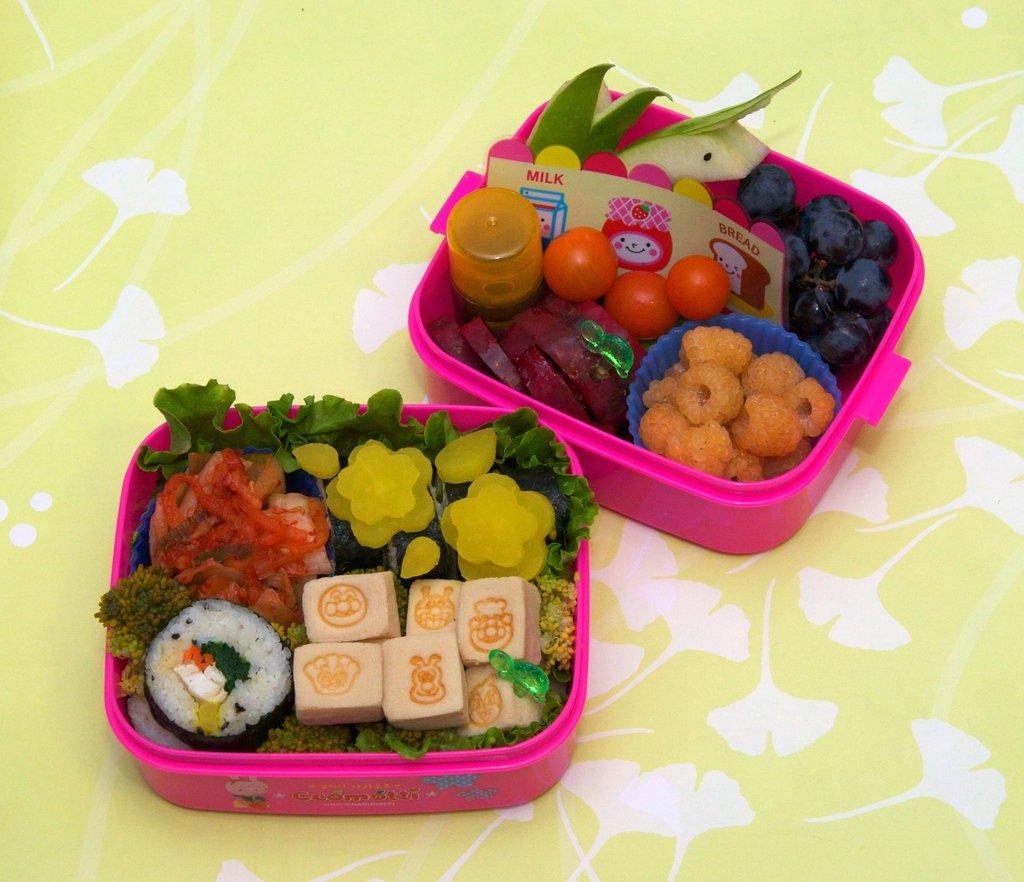What types of items are visible in the image? There are food items in the image. How are the food items stored or contained? The food items are in containers. Where are the containers placed? The containers are placed on a surface. What type of bomb can be seen in the image? There is no bomb present in the image; it features food items in containers placed on a surface. 